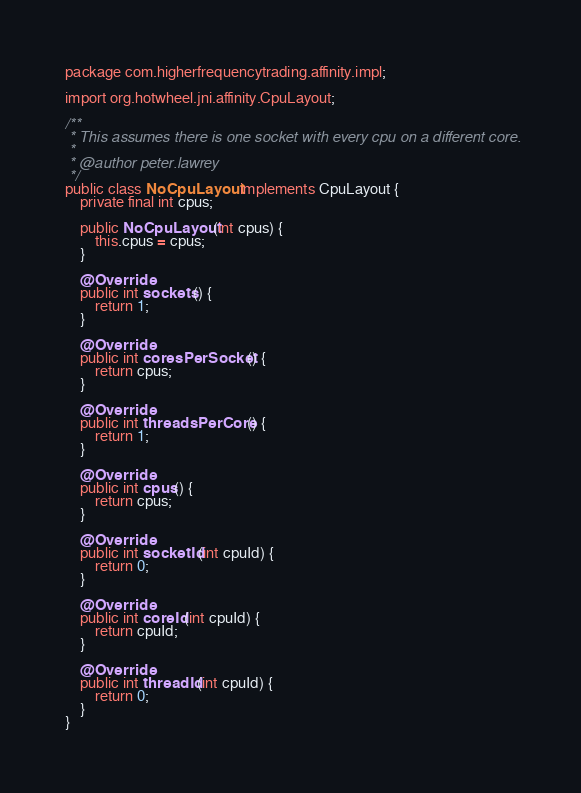<code> <loc_0><loc_0><loc_500><loc_500><_Java_>
package com.higherfrequencytrading.affinity.impl;

import org.hotwheel.jni.affinity.CpuLayout;

/**
 * This assumes there is one socket with every cpu on a different core.
 *
 * @author peter.lawrey
 */
public class NoCpuLayout implements CpuLayout {
    private final int cpus;

    public NoCpuLayout(int cpus) {
        this.cpus = cpus;
    }

    @Override
    public int sockets() {
        return 1;
    }

    @Override
    public int coresPerSocket() {
        return cpus;
    }

    @Override
    public int threadsPerCore() {
        return 1;
    }

    @Override
    public int cpus() {
        return cpus;
    }

    @Override
    public int socketId(int cpuId) {
        return 0;
    }

    @Override
    public int coreId(int cpuId) {
        return cpuId;
    }

    @Override
    public int threadId(int cpuId) {
        return 0;
    }
}
</code> 